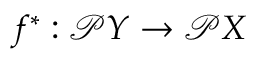<formula> <loc_0><loc_0><loc_500><loc_500>f ^ { * } \colon { \mathcal { P } } Y \to { \mathcal { P } } X</formula> 